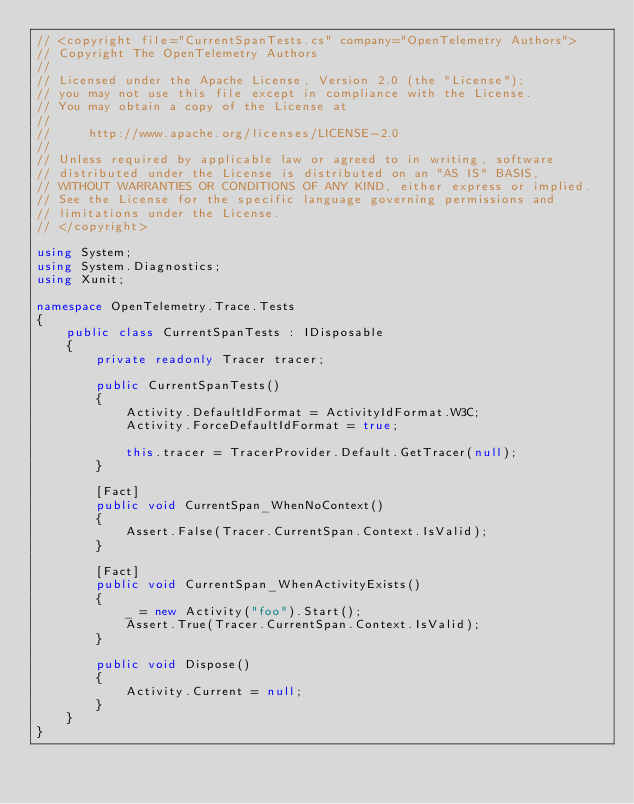Convert code to text. <code><loc_0><loc_0><loc_500><loc_500><_C#_>// <copyright file="CurrentSpanTests.cs" company="OpenTelemetry Authors">
// Copyright The OpenTelemetry Authors
//
// Licensed under the Apache License, Version 2.0 (the "License");
// you may not use this file except in compliance with the License.
// You may obtain a copy of the License at
//
//     http://www.apache.org/licenses/LICENSE-2.0
//
// Unless required by applicable law or agreed to in writing, software
// distributed under the License is distributed on an "AS IS" BASIS,
// WITHOUT WARRANTIES OR CONDITIONS OF ANY KIND, either express or implied.
// See the License for the specific language governing permissions and
// limitations under the License.
// </copyright>

using System;
using System.Diagnostics;
using Xunit;

namespace OpenTelemetry.Trace.Tests
{
    public class CurrentSpanTests : IDisposable
    {
        private readonly Tracer tracer;

        public CurrentSpanTests()
        {
            Activity.DefaultIdFormat = ActivityIdFormat.W3C;
            Activity.ForceDefaultIdFormat = true;

            this.tracer = TracerProvider.Default.GetTracer(null);
        }

        [Fact]
        public void CurrentSpan_WhenNoContext()
        {
            Assert.False(Tracer.CurrentSpan.Context.IsValid);
        }

        [Fact]
        public void CurrentSpan_WhenActivityExists()
        {
            _ = new Activity("foo").Start();
            Assert.True(Tracer.CurrentSpan.Context.IsValid);
        }

        public void Dispose()
        {
            Activity.Current = null;
        }
    }
}
</code> 